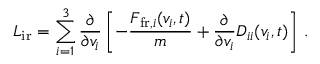<formula> <loc_0><loc_0><loc_500><loc_500>L _ { i r } = \sum _ { i = 1 } ^ { 3 } \frac { \partial } { \partial v _ { i } } \left [ - \frac { F _ { f r , i } ( v _ { i } , t ) } { m } + \frac { \partial } { \partial v _ { i } } D _ { i i } ( v _ { i } , t ) \right ] \, .</formula> 